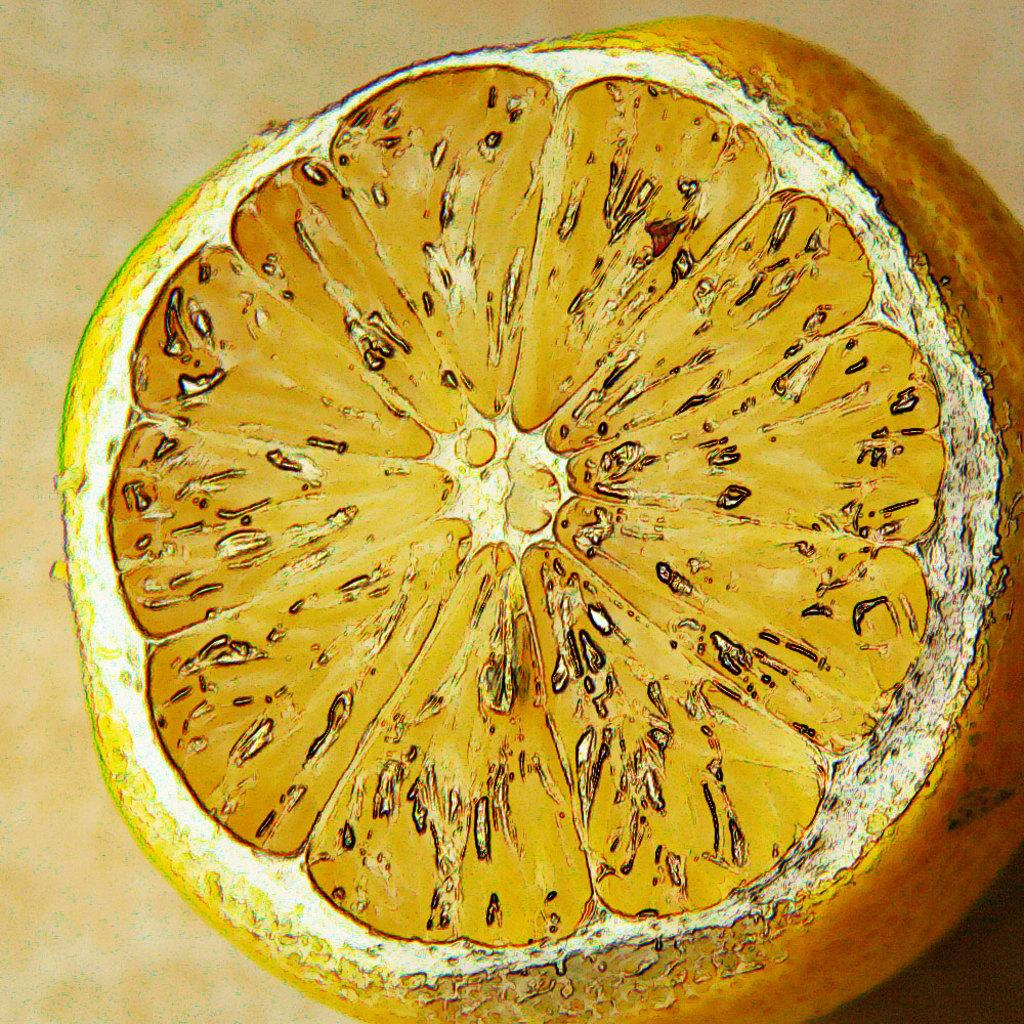What is the main subject of the image? There is a painting in the image. What does the painting depict? The painting depicts an orange fruit. Where is the painting located in the image? The painting is in the center of the image. Can you see any worms crawling on the orange fruit in the painting? There are no worms visible on the orange fruit in the painting; it only depicts the fruit itself. 